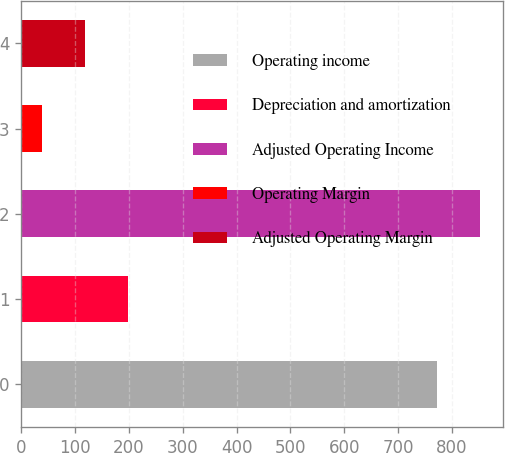Convert chart to OTSL. <chart><loc_0><loc_0><loc_500><loc_500><bar_chart><fcel>Operating income<fcel>Depreciation and amortization<fcel>Adjusted Operating Income<fcel>Operating Margin<fcel>Adjusted Operating Margin<nl><fcel>772.8<fcel>198.24<fcel>852.92<fcel>38<fcel>118.12<nl></chart> 